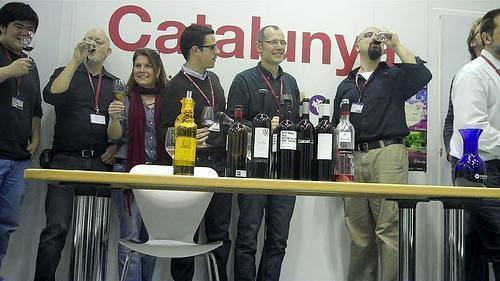What animal name does the first three letters on the wall spell?
Indicate the correct choice and explain in the format: 'Answer: answer
Rationale: rationale.'
Options: Hen, pig, dog, cat. Answer: cat.
Rationale: The animal is a cat. 